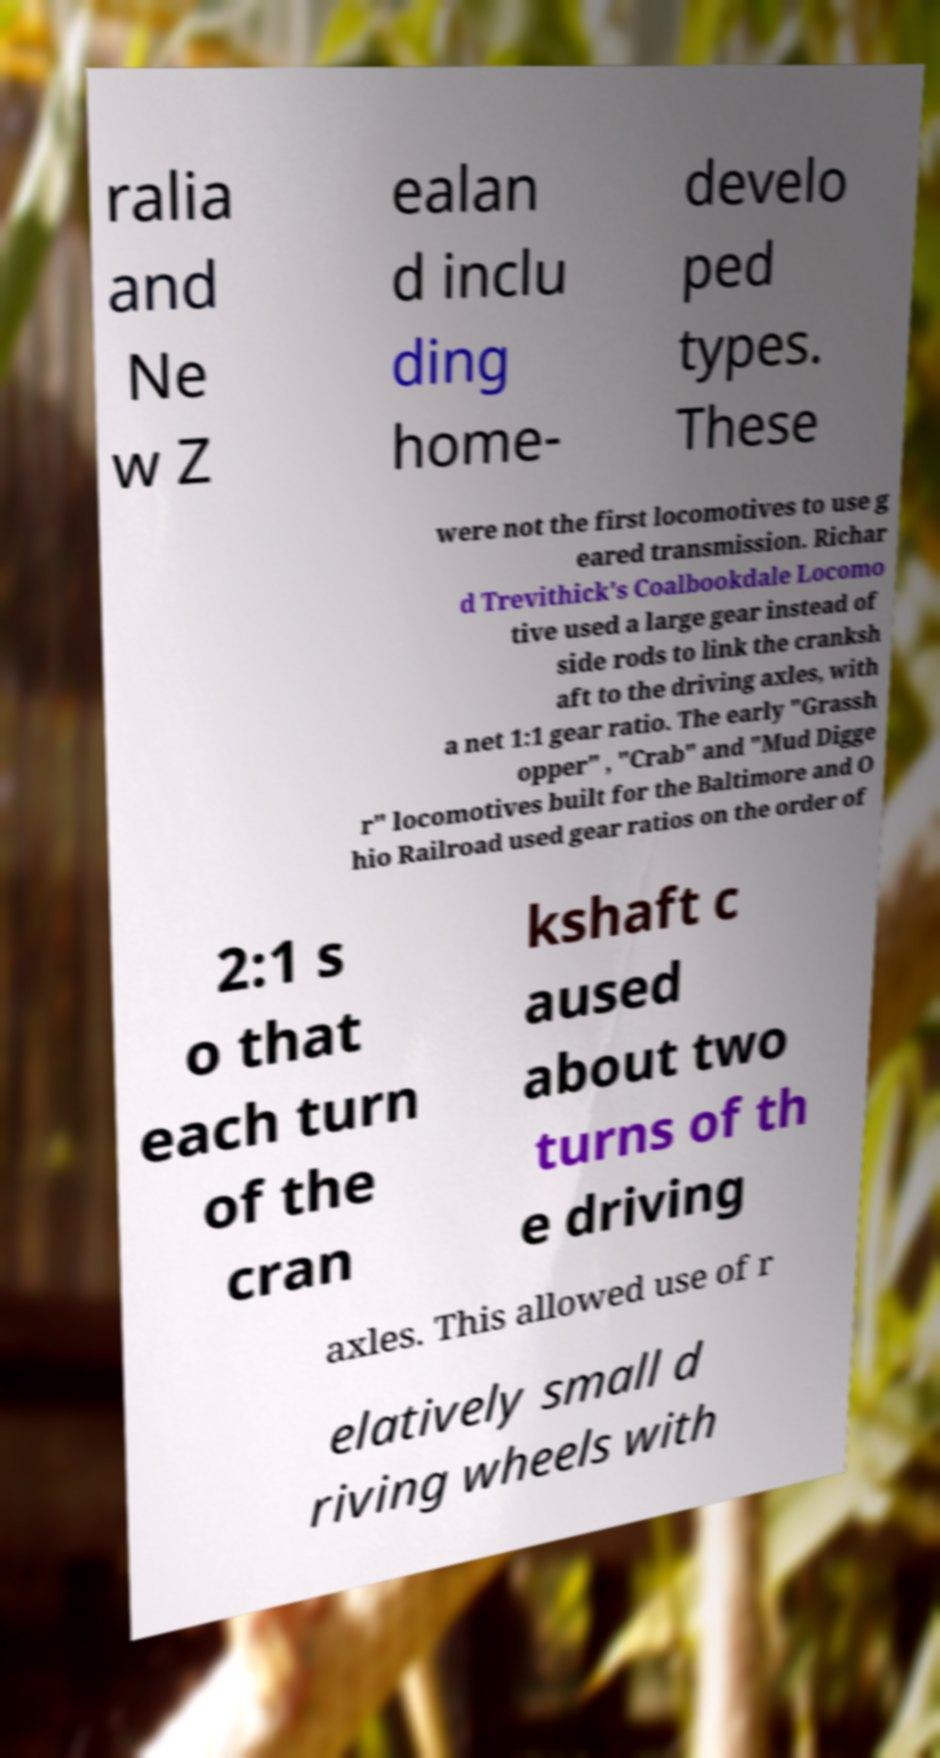Could you extract and type out the text from this image? ralia and Ne w Z ealan d inclu ding home- develo ped types. These were not the first locomotives to use g eared transmission. Richar d Trevithick's Coalbookdale Locomo tive used a large gear instead of side rods to link the cranksh aft to the driving axles, with a net 1:1 gear ratio. The early "Grassh opper" , "Crab" and "Mud Digge r" locomotives built for the Baltimore and O hio Railroad used gear ratios on the order of 2:1 s o that each turn of the cran kshaft c aused about two turns of th e driving axles. This allowed use of r elatively small d riving wheels with 